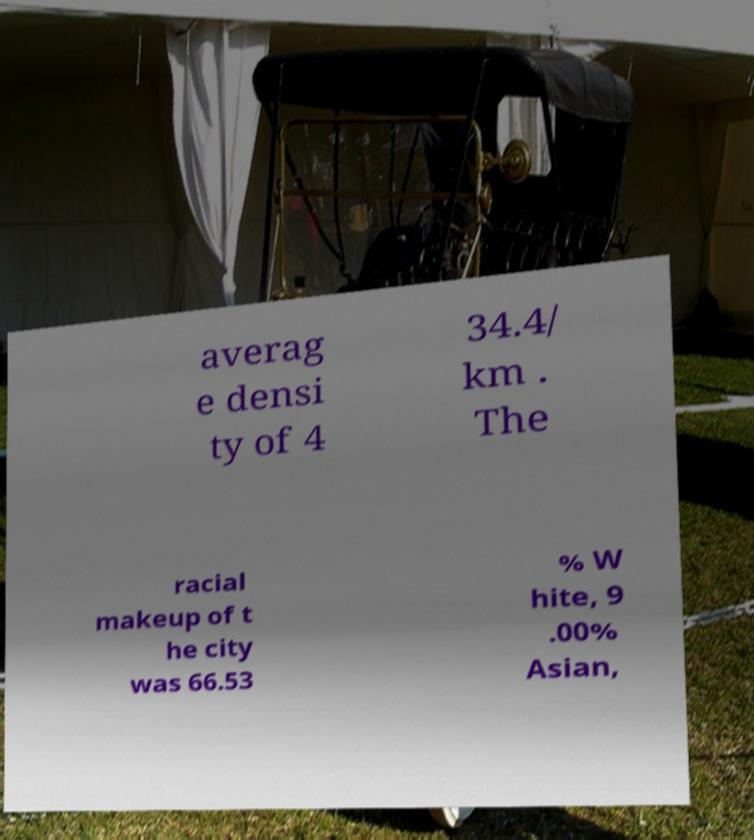What messages or text are displayed in this image? I need them in a readable, typed format. averag e densi ty of 4 34.4/ km . The racial makeup of t he city was 66.53 % W hite, 9 .00% Asian, 